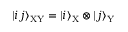<formula> <loc_0><loc_0><loc_500><loc_500>| i j \rangle _ { X Y } = | i \rangle _ { X } \otimes | j \rangle _ { Y }</formula> 